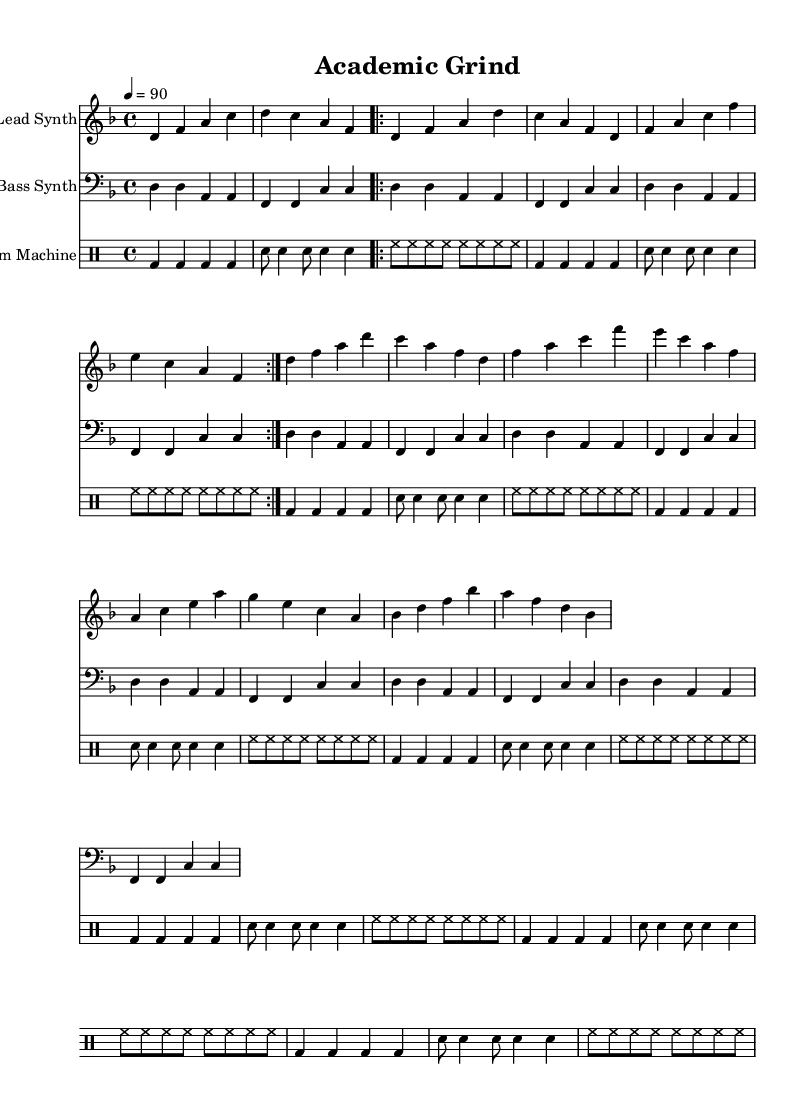What is the key signature of this music? The key signature is D minor, which includes one flat (B flat). This can be observed in the key signature indicated at the beginning of the sheet music.
Answer: D minor What is the time signature of this music? The time signature is 4/4, meaning there are four beats in each measure, and the quarter note receives one beat. This is indicated in the section where the time signature is displayed at the beginning.
Answer: 4/4 What is the tempo marking of the piece? The tempo marking is 90 beats per minute. This is specified at the beginning of the score as "4 = 90", indicating the speed at which the piece should be played.
Answer: 90 How many times is the verse section repeated? The verse section is repeated 2 times as shown by the 'repeat volta 2' instruction present before the verse measures. This indicates the specific section to be played multiple times.
Answer: 2 What instrument plays the bass line? The bass line is played by the Bass Synth, as indicated in the staff instrument name under the bass clef section of the sheet music.
Answer: Bass Synth What is the rhythmic pattern of the drum machine during the first line? The first line features a pattern of bass drums played on the quarter notes, followed by snare drums on alternating eighth and quarter notes, and hi-hats in eighth notes. This is derived by analyzing the drum notation for the first line of the rhythmic pattern.
Answer: Bass drum quarter notes 